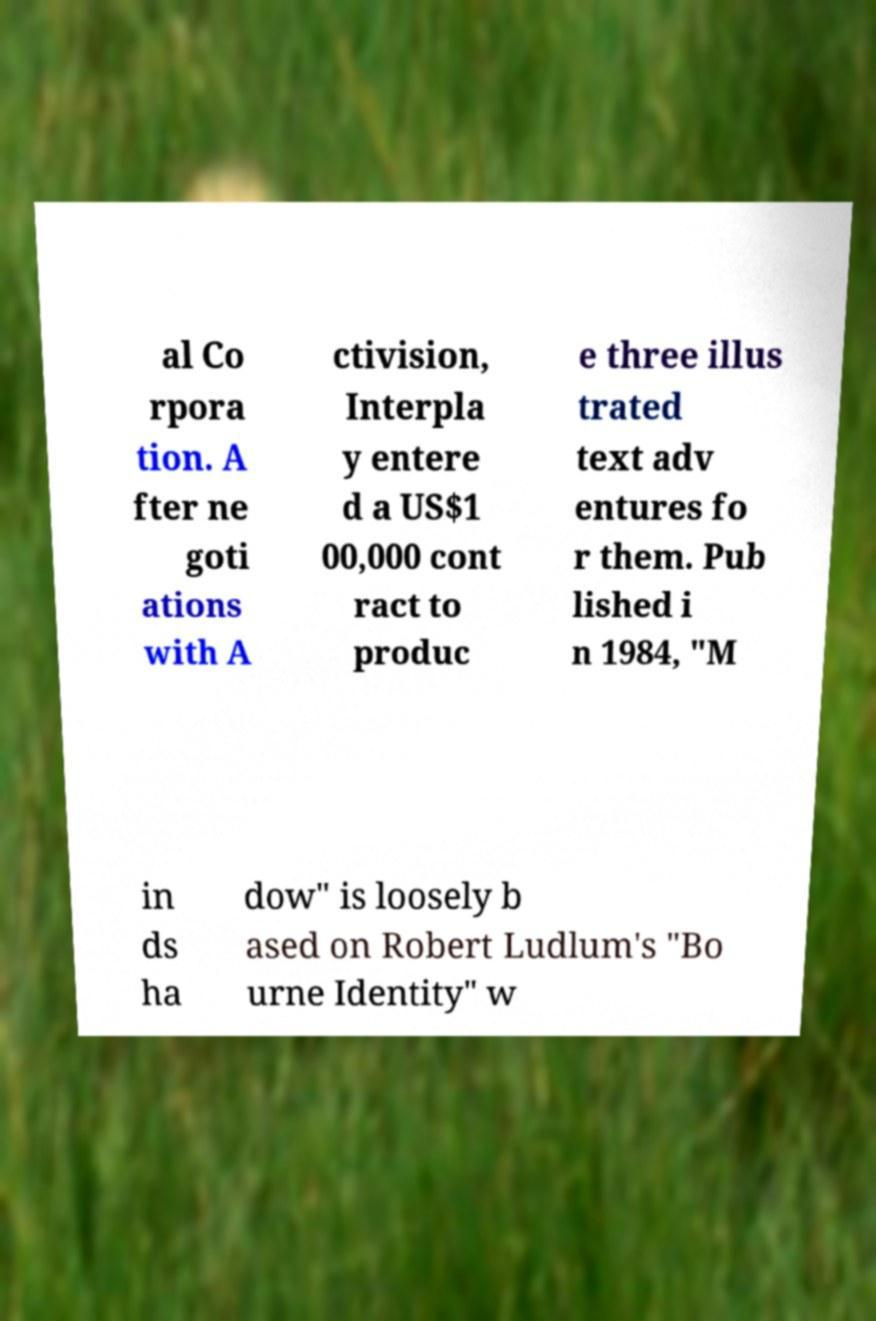Could you assist in decoding the text presented in this image and type it out clearly? al Co rpora tion. A fter ne goti ations with A ctivision, Interpla y entere d a US$1 00,000 cont ract to produc e three illus trated text adv entures fo r them. Pub lished i n 1984, "M in ds ha dow" is loosely b ased on Robert Ludlum's "Bo urne Identity" w 